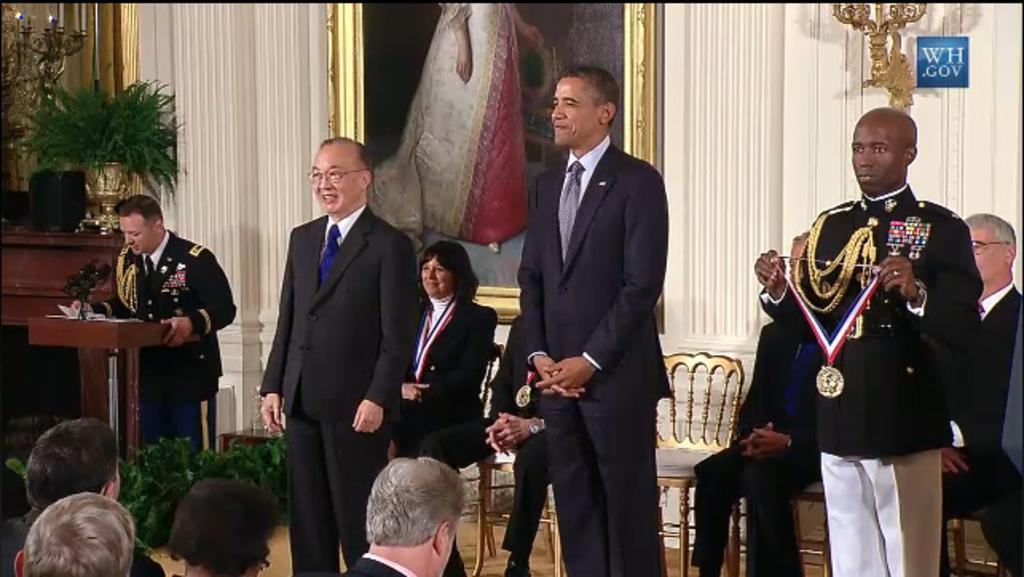In one or two sentences, can you explain what this image depicts? In this image few persons are standing on the stage. A person wearing a black uniform is holding a medal in his hand. Two persons are wearing suits and tie. Behind them two persons are sitting on chair, beside them there is a chair. A person is standing behind a podium having mike and paper on it. Beside there are few plants and a table having glass on it. Bottom of image there are few persons. A picture frame is attached to the wall. Beside there is a lamp attached to the wall. Beside there is a table having a pot with plant, lamp, sound speaker on it. 